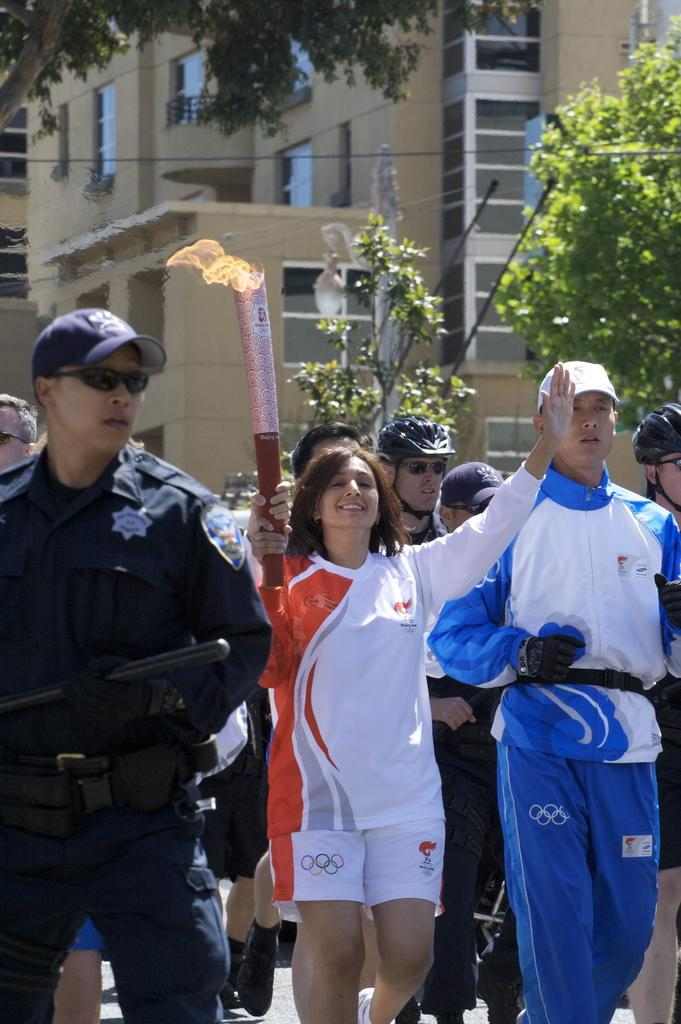How many people are in the image? There are people in the image, but the exact number is not specified. What are some people doing in the image? Some people are holding a torch in the image. What can be seen in the background of the image? There is a building and trees in the background of the image. What side of the building is the achiever standing on in the image? There is no mention of an achiever or a specific side of the building in the image. 